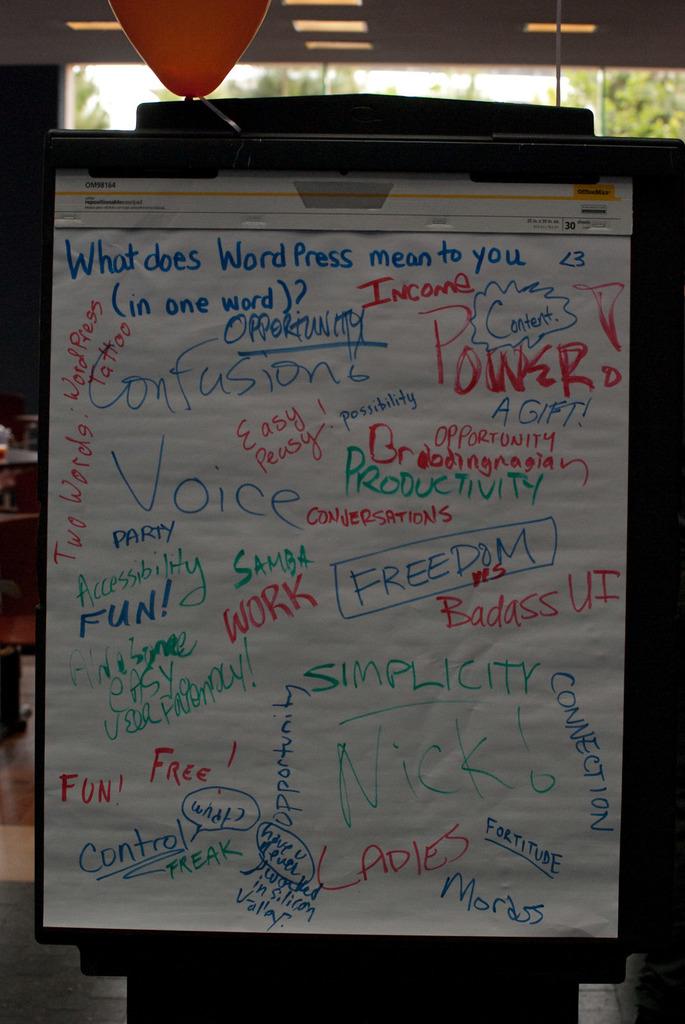What does it ask means to you?
Ensure brevity in your answer.  Wordpress. 